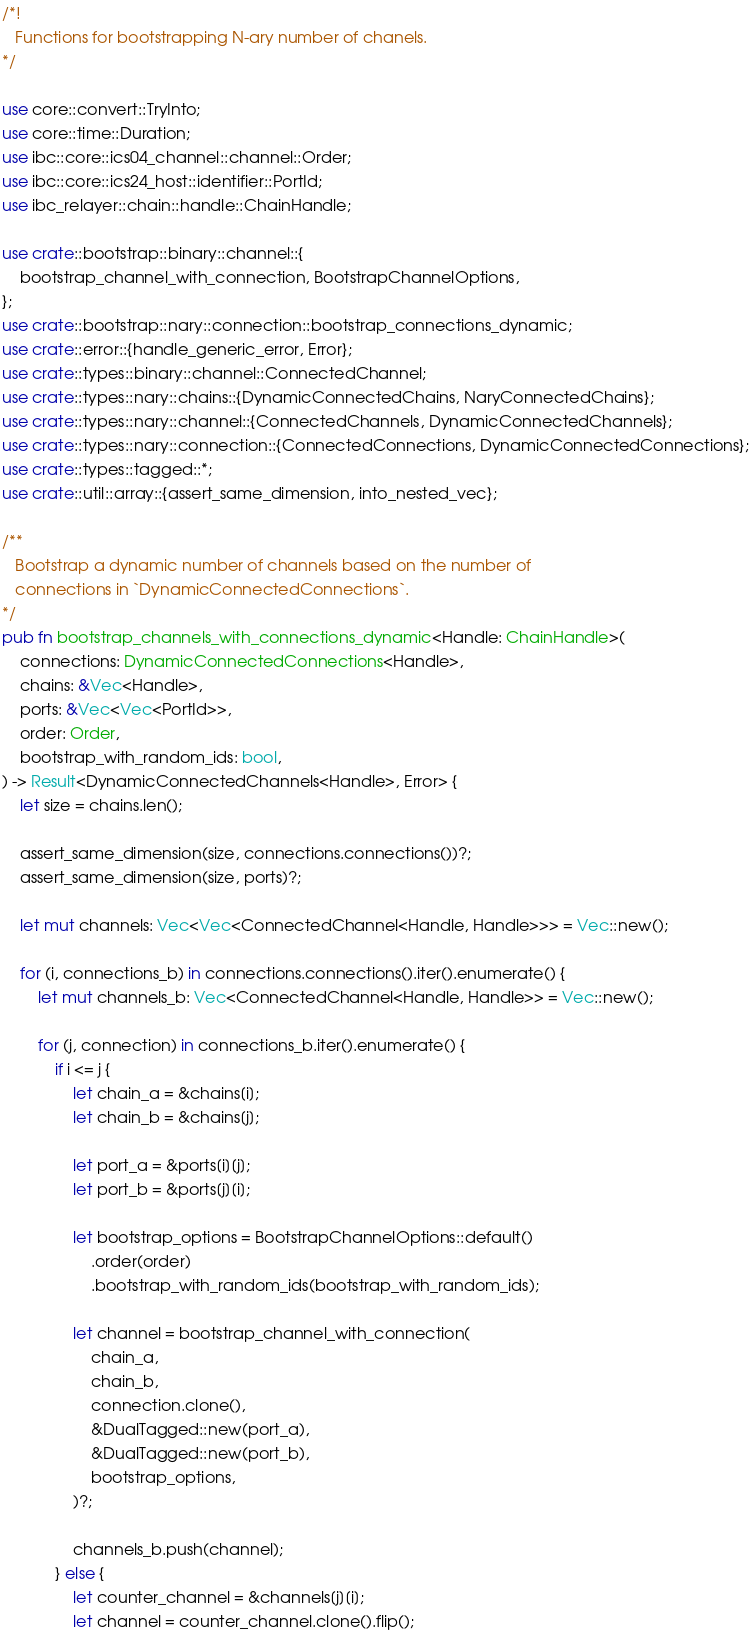<code> <loc_0><loc_0><loc_500><loc_500><_Rust_>/*!
   Functions for bootstrapping N-ary number of chanels.
*/

use core::convert::TryInto;
use core::time::Duration;
use ibc::core::ics04_channel::channel::Order;
use ibc::core::ics24_host::identifier::PortId;
use ibc_relayer::chain::handle::ChainHandle;

use crate::bootstrap::binary::channel::{
    bootstrap_channel_with_connection, BootstrapChannelOptions,
};
use crate::bootstrap::nary::connection::bootstrap_connections_dynamic;
use crate::error::{handle_generic_error, Error};
use crate::types::binary::channel::ConnectedChannel;
use crate::types::nary::chains::{DynamicConnectedChains, NaryConnectedChains};
use crate::types::nary::channel::{ConnectedChannels, DynamicConnectedChannels};
use crate::types::nary::connection::{ConnectedConnections, DynamicConnectedConnections};
use crate::types::tagged::*;
use crate::util::array::{assert_same_dimension, into_nested_vec};

/**
   Bootstrap a dynamic number of channels based on the number of
   connections in `DynamicConnectedConnections`.
*/
pub fn bootstrap_channels_with_connections_dynamic<Handle: ChainHandle>(
    connections: DynamicConnectedConnections<Handle>,
    chains: &Vec<Handle>,
    ports: &Vec<Vec<PortId>>,
    order: Order,
    bootstrap_with_random_ids: bool,
) -> Result<DynamicConnectedChannels<Handle>, Error> {
    let size = chains.len();

    assert_same_dimension(size, connections.connections())?;
    assert_same_dimension(size, ports)?;

    let mut channels: Vec<Vec<ConnectedChannel<Handle, Handle>>> = Vec::new();

    for (i, connections_b) in connections.connections().iter().enumerate() {
        let mut channels_b: Vec<ConnectedChannel<Handle, Handle>> = Vec::new();

        for (j, connection) in connections_b.iter().enumerate() {
            if i <= j {
                let chain_a = &chains[i];
                let chain_b = &chains[j];

                let port_a = &ports[i][j];
                let port_b = &ports[j][i];

                let bootstrap_options = BootstrapChannelOptions::default()
                    .order(order)
                    .bootstrap_with_random_ids(bootstrap_with_random_ids);

                let channel = bootstrap_channel_with_connection(
                    chain_a,
                    chain_b,
                    connection.clone(),
                    &DualTagged::new(port_a),
                    &DualTagged::new(port_b),
                    bootstrap_options,
                )?;

                channels_b.push(channel);
            } else {
                let counter_channel = &channels[j][i];
                let channel = counter_channel.clone().flip();
</code> 